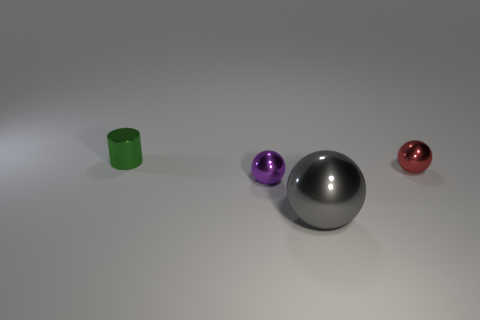Is the shape of the red metal thing the same as the green metallic object?
Your answer should be very brief. No. Is there anything else that is the same material as the red object?
Offer a very short reply. Yes. How many metallic things are in front of the small shiny cylinder and left of the gray thing?
Your answer should be compact. 1. What color is the tiny thing right of the small sphere in front of the tiny red metal sphere?
Offer a very short reply. Red. Is the number of big things that are on the left side of the gray sphere the same as the number of small metallic objects?
Your response must be concise. No. What number of large things are in front of the tiny thing that is in front of the tiny ball that is right of the gray sphere?
Ensure brevity in your answer.  1. There is a sphere right of the large gray ball; what is its color?
Provide a short and direct response. Red. The thing that is both to the right of the small purple thing and behind the gray metal thing is made of what material?
Your response must be concise. Metal. There is a tiny object right of the tiny purple shiny sphere; how many red things are in front of it?
Provide a short and direct response. 0. The tiny purple object is what shape?
Offer a very short reply. Sphere. 